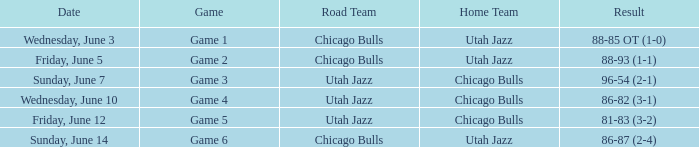Result of 86-87 (2-4) is what game? Game 6. 